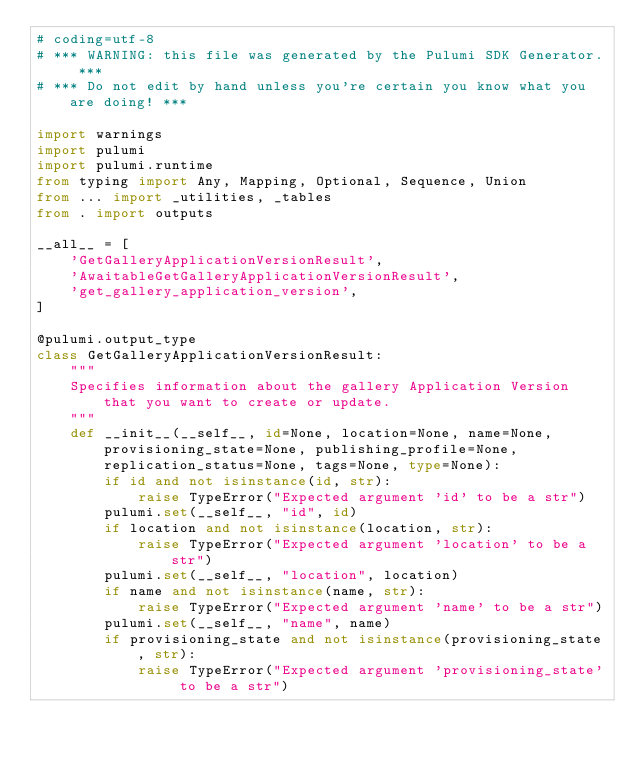<code> <loc_0><loc_0><loc_500><loc_500><_Python_># coding=utf-8
# *** WARNING: this file was generated by the Pulumi SDK Generator. ***
# *** Do not edit by hand unless you're certain you know what you are doing! ***

import warnings
import pulumi
import pulumi.runtime
from typing import Any, Mapping, Optional, Sequence, Union
from ... import _utilities, _tables
from . import outputs

__all__ = [
    'GetGalleryApplicationVersionResult',
    'AwaitableGetGalleryApplicationVersionResult',
    'get_gallery_application_version',
]

@pulumi.output_type
class GetGalleryApplicationVersionResult:
    """
    Specifies information about the gallery Application Version that you want to create or update.
    """
    def __init__(__self__, id=None, location=None, name=None, provisioning_state=None, publishing_profile=None, replication_status=None, tags=None, type=None):
        if id and not isinstance(id, str):
            raise TypeError("Expected argument 'id' to be a str")
        pulumi.set(__self__, "id", id)
        if location and not isinstance(location, str):
            raise TypeError("Expected argument 'location' to be a str")
        pulumi.set(__self__, "location", location)
        if name and not isinstance(name, str):
            raise TypeError("Expected argument 'name' to be a str")
        pulumi.set(__self__, "name", name)
        if provisioning_state and not isinstance(provisioning_state, str):
            raise TypeError("Expected argument 'provisioning_state' to be a str")</code> 